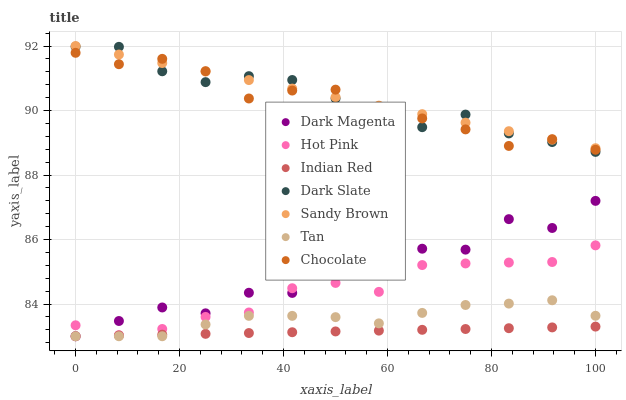Does Indian Red have the minimum area under the curve?
Answer yes or no. Yes. Does Sandy Brown have the maximum area under the curve?
Answer yes or no. Yes. Does Hot Pink have the minimum area under the curve?
Answer yes or no. No. Does Hot Pink have the maximum area under the curve?
Answer yes or no. No. Is Sandy Brown the smoothest?
Answer yes or no. Yes. Is Dark Magenta the roughest?
Answer yes or no. Yes. Is Hot Pink the smoothest?
Answer yes or no. No. Is Hot Pink the roughest?
Answer yes or no. No. Does Dark Magenta have the lowest value?
Answer yes or no. Yes. Does Hot Pink have the lowest value?
Answer yes or no. No. Does Sandy Brown have the highest value?
Answer yes or no. Yes. Does Hot Pink have the highest value?
Answer yes or no. No. Is Tan less than Dark Slate?
Answer yes or no. Yes. Is Sandy Brown greater than Hot Pink?
Answer yes or no. Yes. Does Tan intersect Dark Magenta?
Answer yes or no. Yes. Is Tan less than Dark Magenta?
Answer yes or no. No. Is Tan greater than Dark Magenta?
Answer yes or no. No. Does Tan intersect Dark Slate?
Answer yes or no. No. 